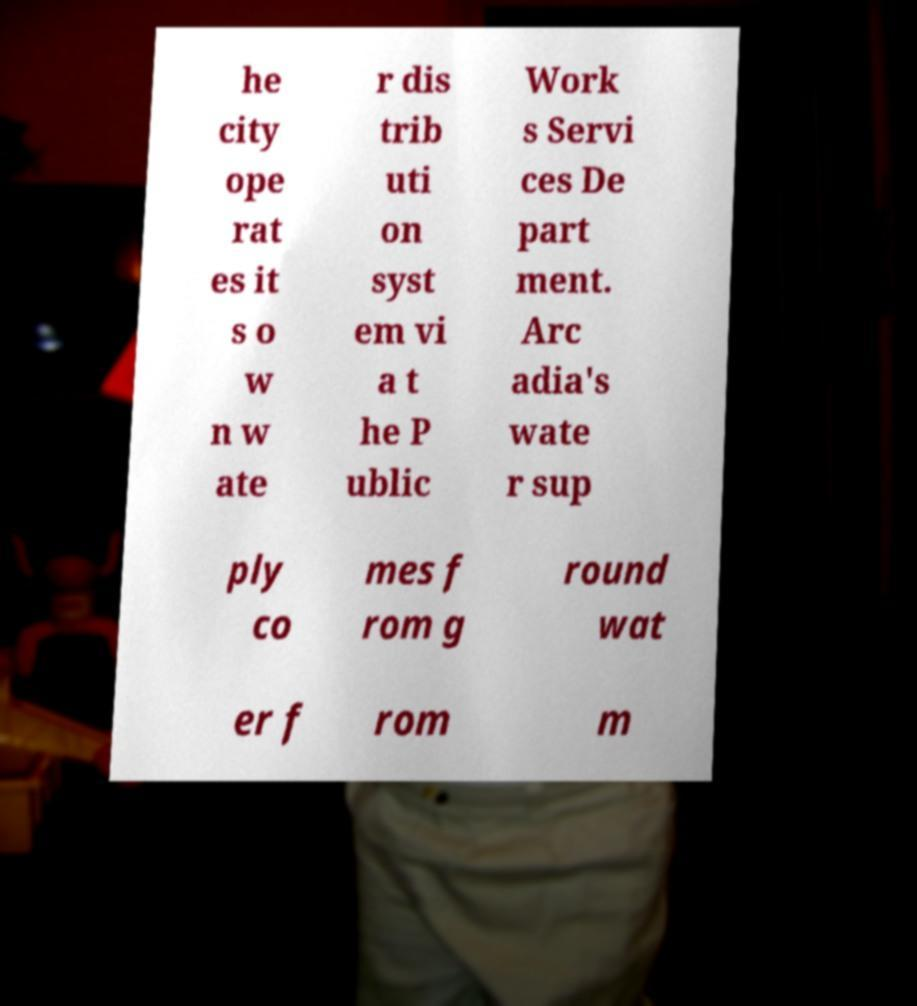For documentation purposes, I need the text within this image transcribed. Could you provide that? he city ope rat es it s o w n w ate r dis trib uti on syst em vi a t he P ublic Work s Servi ces De part ment. Arc adia's wate r sup ply co mes f rom g round wat er f rom m 